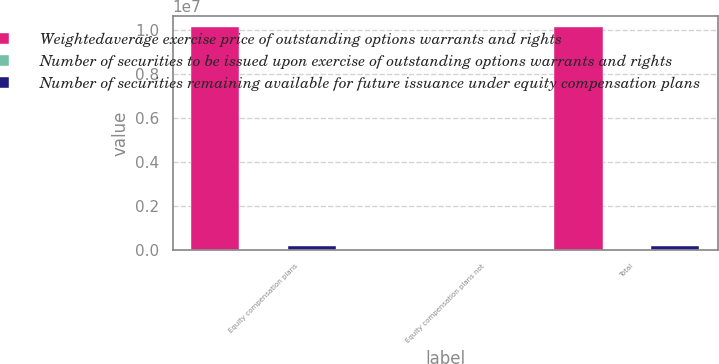<chart> <loc_0><loc_0><loc_500><loc_500><stacked_bar_chart><ecel><fcel>Equity compensation plans<fcel>Equity compensation plans not<fcel>Total<nl><fcel>Weightedaverage exercise price of outstanding options warrants and rights<fcel>1.01238e+07<fcel>0<fcel>1.01238e+07<nl><fcel>Number of securities to be issued upon exercise of outstanding options warrants and rights<fcel>51.14<fcel>0<fcel>51.14<nl><fcel>Number of securities remaining available for future issuance under equity compensation plans<fcel>170176<fcel>0<fcel>170176<nl></chart> 